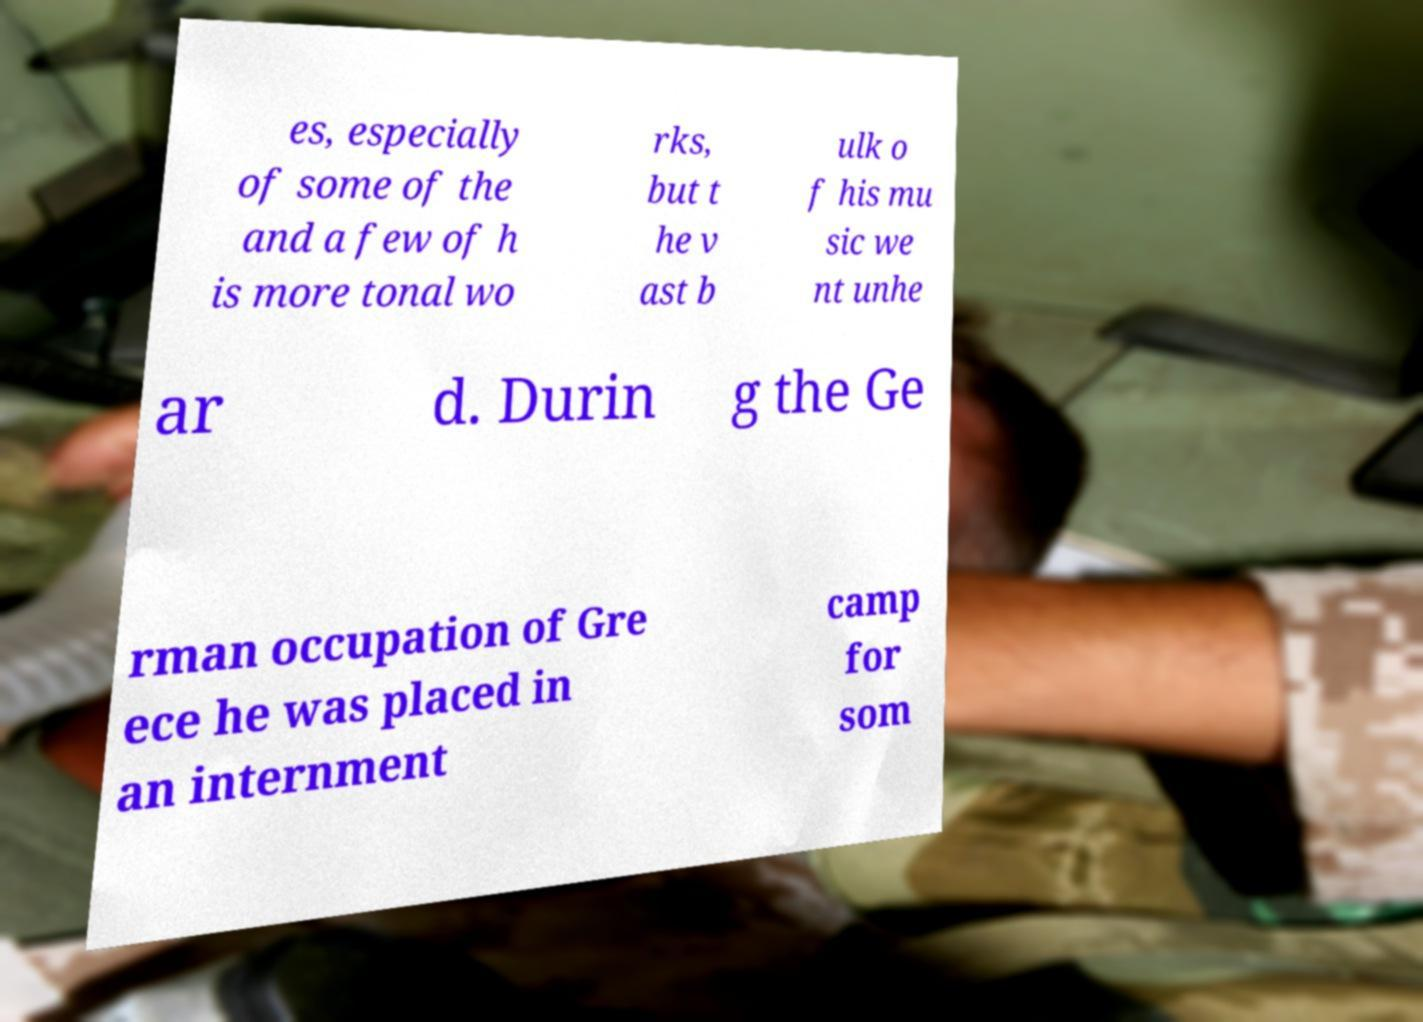Could you assist in decoding the text presented in this image and type it out clearly? es, especially of some of the and a few of h is more tonal wo rks, but t he v ast b ulk o f his mu sic we nt unhe ar d. Durin g the Ge rman occupation of Gre ece he was placed in an internment camp for som 